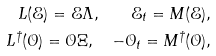<formula> <loc_0><loc_0><loc_500><loc_500>L ( \mathcal { E } ) = \mathcal { E } \Lambda , \quad \mathcal { E } _ { t } = M ( \mathcal { E } ) , \\ L ^ { \dagger } ( \mathcal { O } ) = \mathcal { O } \Xi , \quad - \mathcal { O } _ { t } = M ^ { \dagger } ( \mathcal { O } ) ,</formula> 